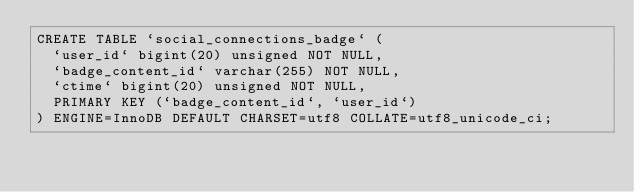Convert code to text. <code><loc_0><loc_0><loc_500><loc_500><_SQL_>CREATE TABLE `social_connections_badge` (
  `user_id` bigint(20) unsigned NOT NULL,
  `badge_content_id` varchar(255) NOT NULL,
  `ctime` bigint(20) unsigned NOT NULL,
  PRIMARY KEY (`badge_content_id`, `user_id`)
) ENGINE=InnoDB DEFAULT CHARSET=utf8 COLLATE=utf8_unicode_ci;
</code> 